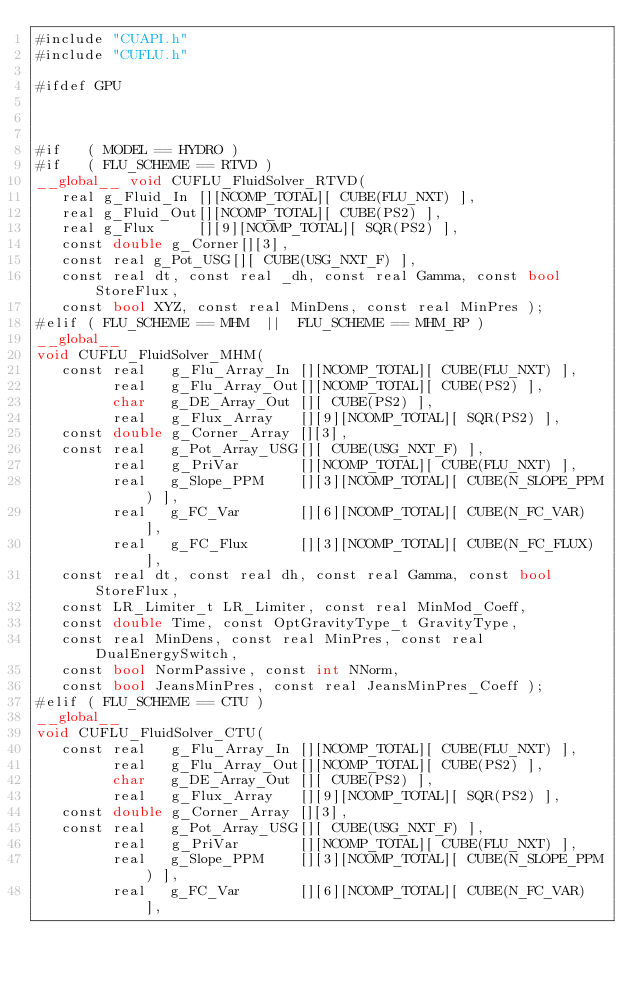<code> <loc_0><loc_0><loc_500><loc_500><_Cuda_>#include "CUAPI.h"
#include "CUFLU.h"

#ifdef GPU



#if   ( MODEL == HYDRO )
#if   ( FLU_SCHEME == RTVD )
__global__ void CUFLU_FluidSolver_RTVD(
   real g_Fluid_In [][NCOMP_TOTAL][ CUBE(FLU_NXT) ],
   real g_Fluid_Out[][NCOMP_TOTAL][ CUBE(PS2) ],
   real g_Flux     [][9][NCOMP_TOTAL][ SQR(PS2) ],
   const double g_Corner[][3],
   const real g_Pot_USG[][ CUBE(USG_NXT_F) ],
   const real dt, const real _dh, const real Gamma, const bool StoreFlux,
   const bool XYZ, const real MinDens, const real MinPres );
#elif ( FLU_SCHEME == MHM  ||  FLU_SCHEME == MHM_RP )
__global__
void CUFLU_FluidSolver_MHM(
   const real   g_Flu_Array_In [][NCOMP_TOTAL][ CUBE(FLU_NXT) ],
         real   g_Flu_Array_Out[][NCOMP_TOTAL][ CUBE(PS2) ],
         char   g_DE_Array_Out [][ CUBE(PS2) ],
         real   g_Flux_Array   [][9][NCOMP_TOTAL][ SQR(PS2) ],
   const double g_Corner_Array [][3],
   const real   g_Pot_Array_USG[][ CUBE(USG_NXT_F) ],
         real   g_PriVar       [][NCOMP_TOTAL][ CUBE(FLU_NXT) ],
         real   g_Slope_PPM    [][3][NCOMP_TOTAL][ CUBE(N_SLOPE_PPM) ],
         real   g_FC_Var       [][6][NCOMP_TOTAL][ CUBE(N_FC_VAR) ],
         real   g_FC_Flux      [][3][NCOMP_TOTAL][ CUBE(N_FC_FLUX) ],
   const real dt, const real dh, const real Gamma, const bool StoreFlux,
   const LR_Limiter_t LR_Limiter, const real MinMod_Coeff,
   const double Time, const OptGravityType_t GravityType,
   const real MinDens, const real MinPres, const real DualEnergySwitch,
   const bool NormPassive, const int NNorm,
   const bool JeansMinPres, const real JeansMinPres_Coeff );
#elif ( FLU_SCHEME == CTU )
__global__
void CUFLU_FluidSolver_CTU(
   const real   g_Flu_Array_In [][NCOMP_TOTAL][ CUBE(FLU_NXT) ],
         real   g_Flu_Array_Out[][NCOMP_TOTAL][ CUBE(PS2) ],
         char   g_DE_Array_Out [][ CUBE(PS2) ],
         real   g_Flux_Array   [][9][NCOMP_TOTAL][ SQR(PS2) ],
   const double g_Corner_Array [][3],
   const real   g_Pot_Array_USG[][ CUBE(USG_NXT_F) ],
         real   g_PriVar       [][NCOMP_TOTAL][ CUBE(FLU_NXT) ],
         real   g_Slope_PPM    [][3][NCOMP_TOTAL][ CUBE(N_SLOPE_PPM) ],
         real   g_FC_Var       [][6][NCOMP_TOTAL][ CUBE(N_FC_VAR) ],</code> 